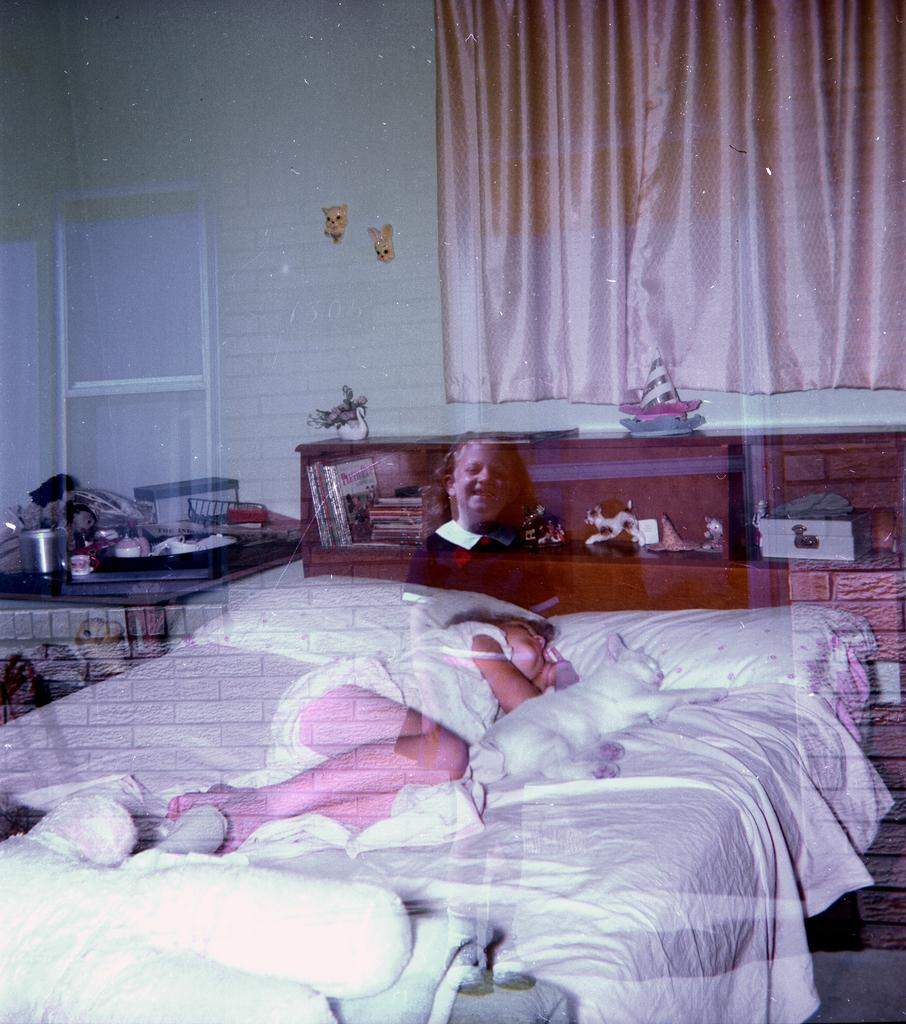What is the girl doing in the image? The girl is lying on the bed in the image. Is there any other living creature with the girl on the bed? Yes, there is a cat with the girl on the bed. What is the illusion of in the image? There is an illusion of a girl standing in the image. What type of cake is being served by the police officer in the image? There is no cake or police officer present in the image. 